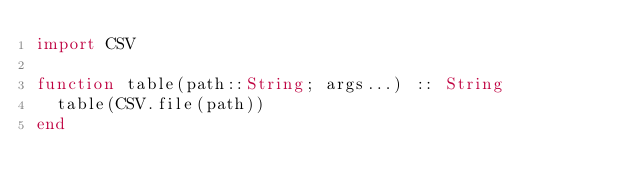Convert code to text. <code><loc_0><loc_0><loc_500><loc_500><_Julia_>import CSV

function table(path::String; args...) :: String
  table(CSV.file(path))
end</code> 